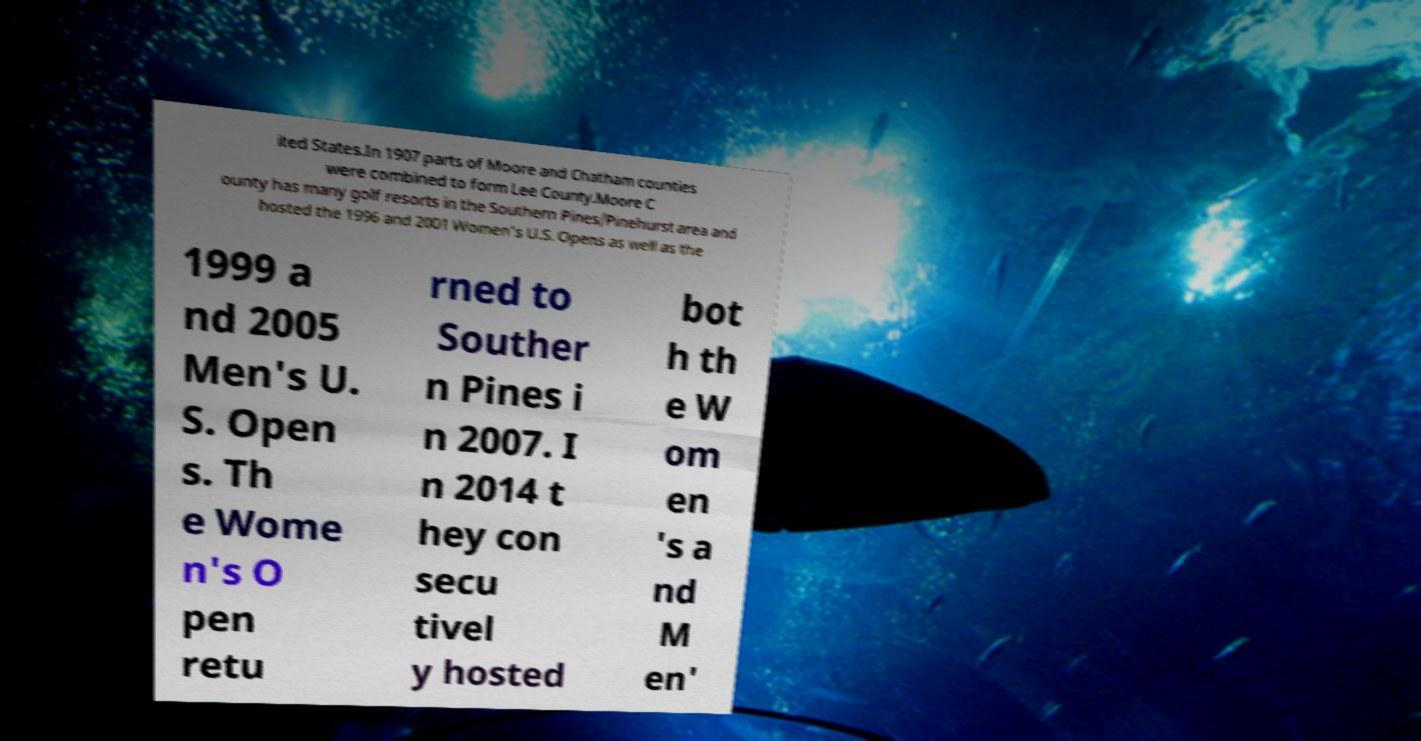I need the written content from this picture converted into text. Can you do that? ited States.In 1907 parts of Moore and Chatham counties were combined to form Lee County.Moore C ounty has many golf resorts in the Southern Pines/Pinehurst area and hosted the 1996 and 2001 Women's U.S. Opens as well as the 1999 a nd 2005 Men's U. S. Open s. Th e Wome n's O pen retu rned to Souther n Pines i n 2007. I n 2014 t hey con secu tivel y hosted bot h th e W om en 's a nd M en' 